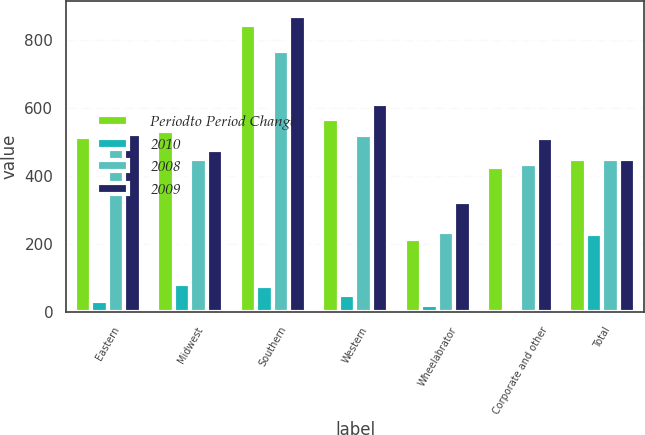<chart> <loc_0><loc_0><loc_500><loc_500><stacked_bar_chart><ecel><fcel>Eastern<fcel>Midwest<fcel>Southern<fcel>Western<fcel>Wheelabrator<fcel>Corporate and other<fcel>Total<nl><fcel>Periodto Period Change<fcel>516<fcel>533<fcel>844<fcel>569<fcel>214<fcel>425<fcel>450<nl><fcel>2010<fcel>33<fcel>83<fcel>76<fcel>48<fcel>21<fcel>9<fcel>229<nl><fcel>2008<fcel>483<fcel>450<fcel>768<fcel>521<fcel>235<fcel>434<fcel>450<nl><fcel>2009<fcel>523<fcel>475<fcel>872<fcel>612<fcel>323<fcel>511<fcel>450<nl></chart> 